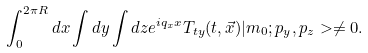Convert formula to latex. <formula><loc_0><loc_0><loc_500><loc_500>\int _ { 0 } ^ { 2 \pi R } d x \int d y \int d z e ^ { i q _ { x } x } T _ { t y } ( t , \vec { x } ) | m _ { 0 } ; p _ { y } , p _ { z } > \neq 0 .</formula> 